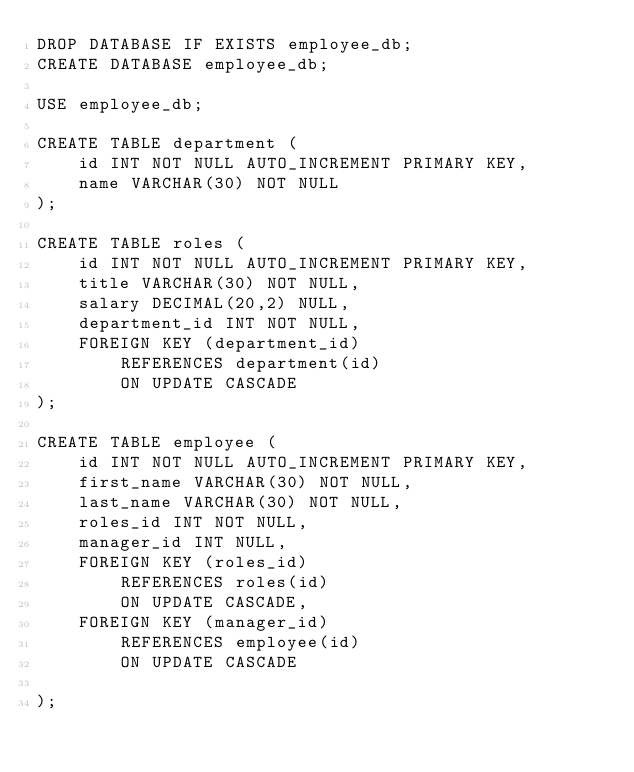<code> <loc_0><loc_0><loc_500><loc_500><_SQL_>DROP DATABASE IF EXISTS employee_db;
CREATE DATABASE employee_db;

USE employee_db;

CREATE TABLE department (
    id INT NOT NULL AUTO_INCREMENT PRIMARY KEY,
    name VARCHAR(30) NOT NULL
);

CREATE TABLE roles (
    id INT NOT NULL AUTO_INCREMENT PRIMARY KEY,
    title VARCHAR(30) NOT NULL,
    salary DECIMAL(20,2) NULL,
    department_id INT NOT NULL,
    FOREIGN KEY (department_id)
        REFERENCES department(id)
        ON UPDATE CASCADE
);

CREATE TABLE employee (
    id INT NOT NULL AUTO_INCREMENT PRIMARY KEY,
    first_name VARCHAR(30) NOT NULL,
    last_name VARCHAR(30) NOT NULL,
    roles_id INT NOT NULL,
    manager_id INT NULL,
    FOREIGN KEY (roles_id)
        REFERENCES roles(id)
        ON UPDATE CASCADE,
    FOREIGN KEY (manager_id)
        REFERENCES employee(id)
        ON UPDATE CASCADE

);</code> 